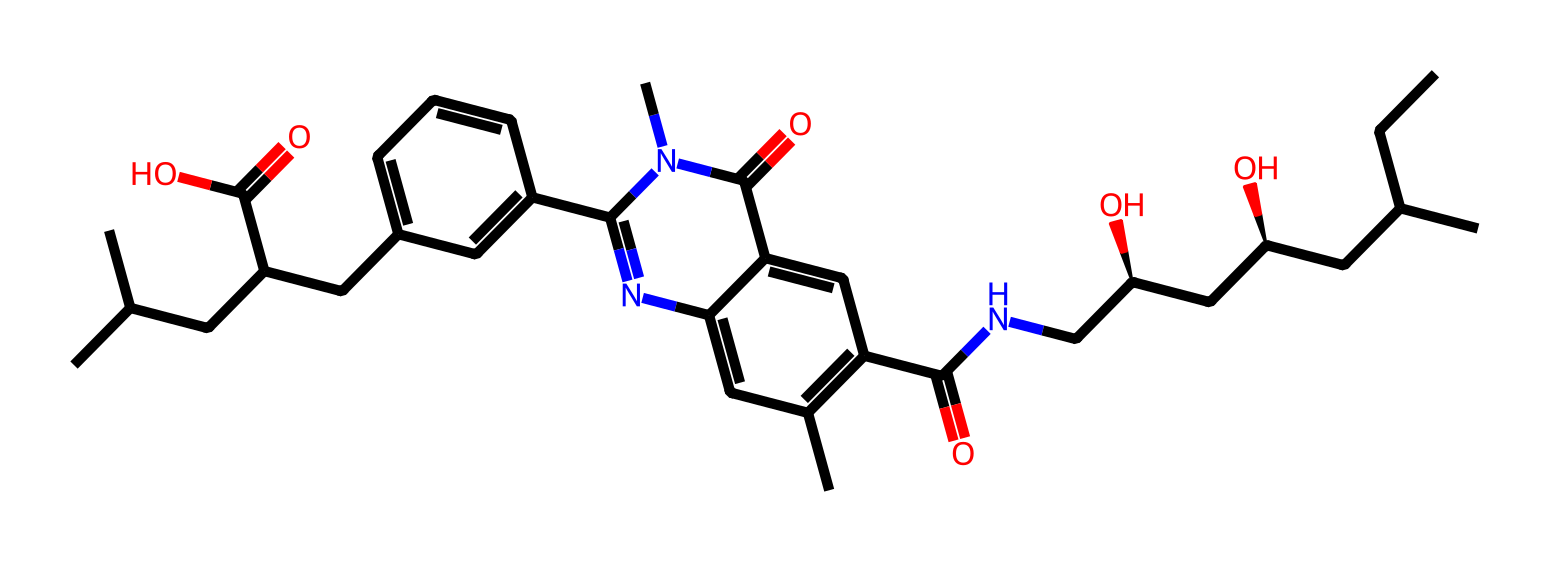what is the primary functional group of this chemical? The chemical contains a carboxylic acid group (-COOH) indicated by the presence of a carbon atom bonded to a hydroxyl group (-OH) and a carbonyl group (C=O). This is the defining characteristic of a carboxylic acid.
Answer: carboxylic acid how many nitrogen atoms are present in this structure? By examining the SMILES representation, it’s clear that there are two nitrogen atoms present in the structure, specifically indicated by the "n" characters in the string.
Answer: 2 which part of the molecule is responsible for its pharmacological activity? The pharmacological activity often depends on specific functional groups and their interactions within the biological system. In this molecule, the nitrogen atoms and the carboxylic acid functional group tend to influence the pharmacological properties significantly.
Answer: nitrogen and carboxylic acid what is the total number of carbon atoms in this molecule? Counting the carbon atoms systematically from the SMILES representation reveals that there are 30 total carbon atoms present in this chemical structure.
Answer: 30 is this compound more likely to be hydrophilic or hydrophobic? The presence of multiple polar functional groups, including hydroxyl (-OH) and carboxylic acid (-COOH), suggests that this compound would have strong interactions with water, indicating it is more likely hydrophilic.
Answer: hydrophilic what type of drug role does this compound serve in cholesterol management? This compound is a statin, a class of drugs that inhibit the enzyme HMG-CoA reductase, which plays a central role in cholesterol biosynthesis, thereby lowering cholesterol levels in the blood.
Answer: statin 